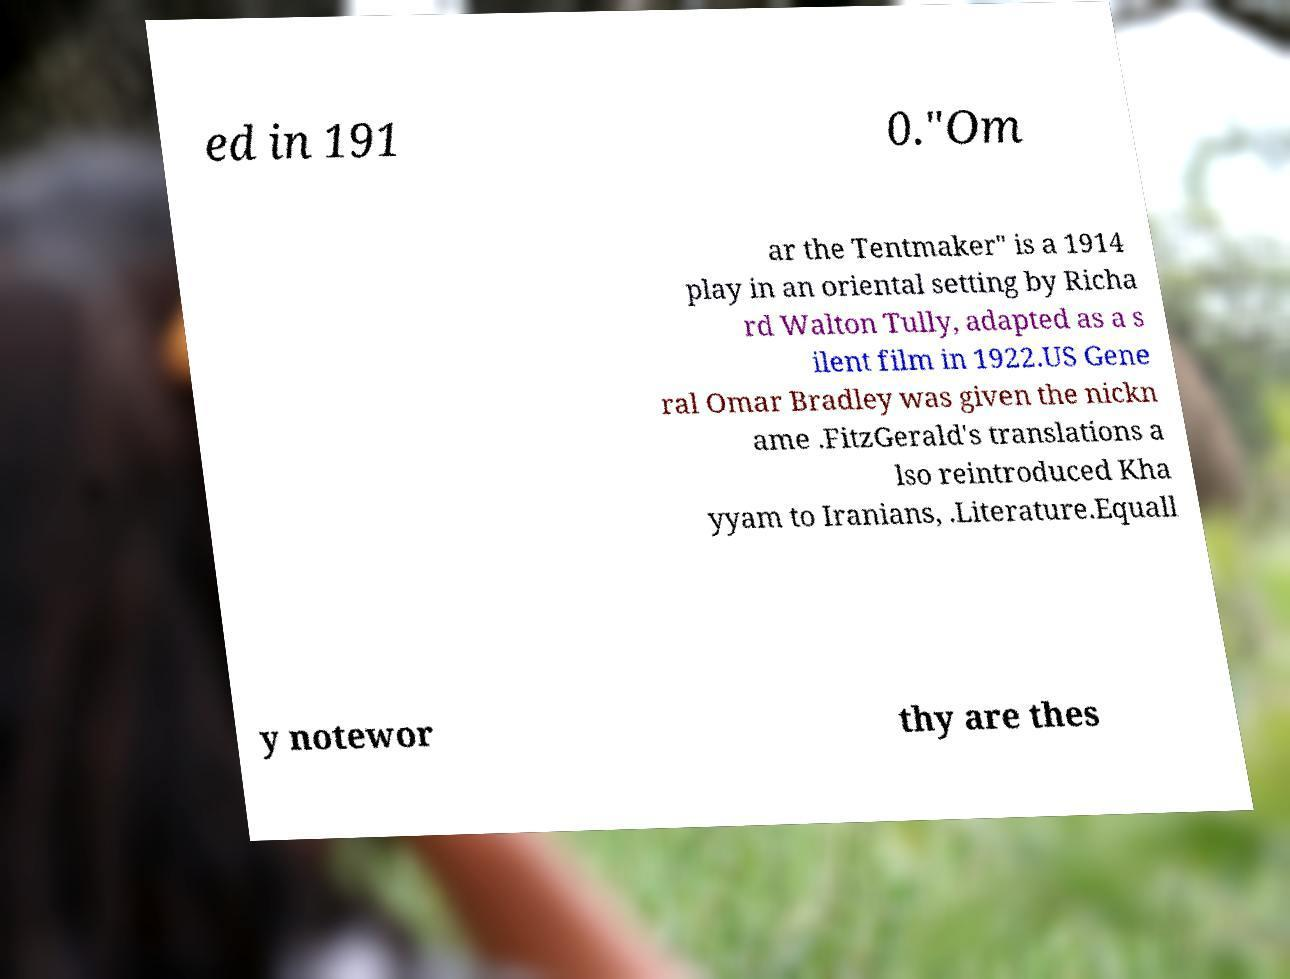What messages or text are displayed in this image? I need them in a readable, typed format. ed in 191 0."Om ar the Tentmaker" is a 1914 play in an oriental setting by Richa rd Walton Tully, adapted as a s ilent film in 1922.US Gene ral Omar Bradley was given the nickn ame .FitzGerald's translations a lso reintroduced Kha yyam to Iranians, .Literature.Equall y notewor thy are thes 